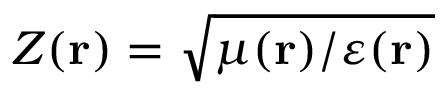Convert formula to latex. <formula><loc_0><loc_0><loc_500><loc_500>Z ( r ) = \sqrt { \mu ( r ) / \varepsilon ( r ) }</formula> 